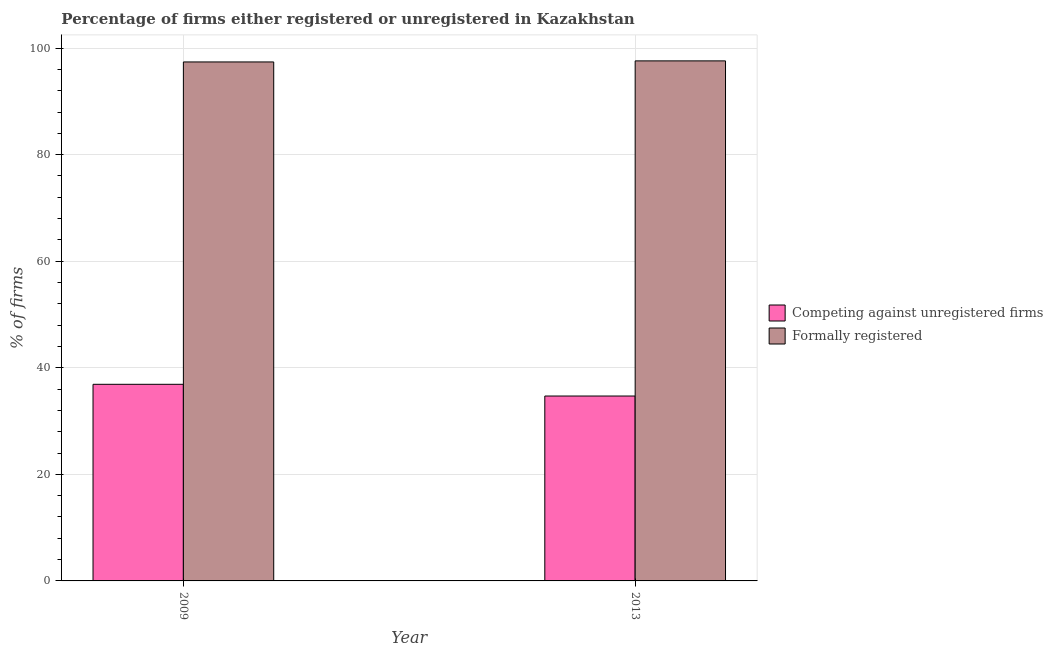How many different coloured bars are there?
Your response must be concise. 2. Are the number of bars per tick equal to the number of legend labels?
Make the answer very short. Yes. How many bars are there on the 1st tick from the left?
Your answer should be very brief. 2. How many bars are there on the 1st tick from the right?
Keep it short and to the point. 2. What is the label of the 2nd group of bars from the left?
Keep it short and to the point. 2013. In how many cases, is the number of bars for a given year not equal to the number of legend labels?
Make the answer very short. 0. What is the percentage of registered firms in 2009?
Your response must be concise. 36.9. Across all years, what is the maximum percentage of formally registered firms?
Give a very brief answer. 97.6. Across all years, what is the minimum percentage of formally registered firms?
Give a very brief answer. 97.4. In which year was the percentage of formally registered firms maximum?
Make the answer very short. 2013. In which year was the percentage of formally registered firms minimum?
Offer a terse response. 2009. What is the total percentage of registered firms in the graph?
Offer a very short reply. 71.6. What is the difference between the percentage of formally registered firms in 2009 and that in 2013?
Give a very brief answer. -0.2. What is the difference between the percentage of formally registered firms in 2009 and the percentage of registered firms in 2013?
Provide a short and direct response. -0.2. What is the average percentage of registered firms per year?
Provide a succinct answer. 35.8. What is the ratio of the percentage of formally registered firms in 2009 to that in 2013?
Offer a terse response. 1. In how many years, is the percentage of registered firms greater than the average percentage of registered firms taken over all years?
Your response must be concise. 1. What does the 1st bar from the left in 2009 represents?
Give a very brief answer. Competing against unregistered firms. What does the 2nd bar from the right in 2013 represents?
Provide a short and direct response. Competing against unregistered firms. How many bars are there?
Offer a very short reply. 4. Are all the bars in the graph horizontal?
Provide a short and direct response. No. How many years are there in the graph?
Your answer should be very brief. 2. Are the values on the major ticks of Y-axis written in scientific E-notation?
Make the answer very short. No. Does the graph contain any zero values?
Keep it short and to the point. No. Does the graph contain grids?
Provide a succinct answer. Yes. Where does the legend appear in the graph?
Provide a succinct answer. Center right. How are the legend labels stacked?
Provide a succinct answer. Vertical. What is the title of the graph?
Give a very brief answer. Percentage of firms either registered or unregistered in Kazakhstan. What is the label or title of the X-axis?
Give a very brief answer. Year. What is the label or title of the Y-axis?
Your answer should be very brief. % of firms. What is the % of firms of Competing against unregistered firms in 2009?
Your response must be concise. 36.9. What is the % of firms in Formally registered in 2009?
Ensure brevity in your answer.  97.4. What is the % of firms in Competing against unregistered firms in 2013?
Your answer should be compact. 34.7. What is the % of firms in Formally registered in 2013?
Make the answer very short. 97.6. Across all years, what is the maximum % of firms in Competing against unregistered firms?
Offer a terse response. 36.9. Across all years, what is the maximum % of firms of Formally registered?
Give a very brief answer. 97.6. Across all years, what is the minimum % of firms of Competing against unregistered firms?
Your answer should be compact. 34.7. Across all years, what is the minimum % of firms in Formally registered?
Provide a succinct answer. 97.4. What is the total % of firms of Competing against unregistered firms in the graph?
Your answer should be compact. 71.6. What is the total % of firms of Formally registered in the graph?
Give a very brief answer. 195. What is the difference between the % of firms in Competing against unregistered firms in 2009 and that in 2013?
Keep it short and to the point. 2.2. What is the difference between the % of firms of Formally registered in 2009 and that in 2013?
Your answer should be very brief. -0.2. What is the difference between the % of firms in Competing against unregistered firms in 2009 and the % of firms in Formally registered in 2013?
Your answer should be compact. -60.7. What is the average % of firms in Competing against unregistered firms per year?
Provide a short and direct response. 35.8. What is the average % of firms in Formally registered per year?
Keep it short and to the point. 97.5. In the year 2009, what is the difference between the % of firms in Competing against unregistered firms and % of firms in Formally registered?
Ensure brevity in your answer.  -60.5. In the year 2013, what is the difference between the % of firms of Competing against unregistered firms and % of firms of Formally registered?
Offer a very short reply. -62.9. What is the ratio of the % of firms in Competing against unregistered firms in 2009 to that in 2013?
Make the answer very short. 1.06. What is the ratio of the % of firms of Formally registered in 2009 to that in 2013?
Ensure brevity in your answer.  1. What is the difference between the highest and the second highest % of firms in Formally registered?
Offer a terse response. 0.2. What is the difference between the highest and the lowest % of firms of Formally registered?
Provide a short and direct response. 0.2. 